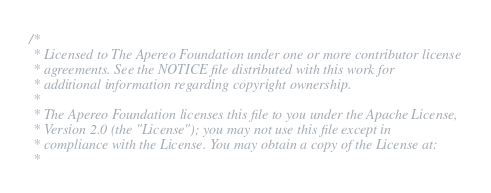Convert code to text. <code><loc_0><loc_0><loc_500><loc_500><_SQL_>/*
 * Licensed to The Apereo Foundation under one or more contributor license
 * agreements. See the NOTICE file distributed with this work for
 * additional information regarding copyright ownership.
 *
 * The Apereo Foundation licenses this file to you under the Apache License,
 * Version 2.0 (the "License"); you may not use this file except in
 * compliance with the License. You may obtain a copy of the License at:
 *</code> 